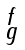<formula> <loc_0><loc_0><loc_500><loc_500>\begin{smallmatrix} f \\ g \end{smallmatrix}</formula> 